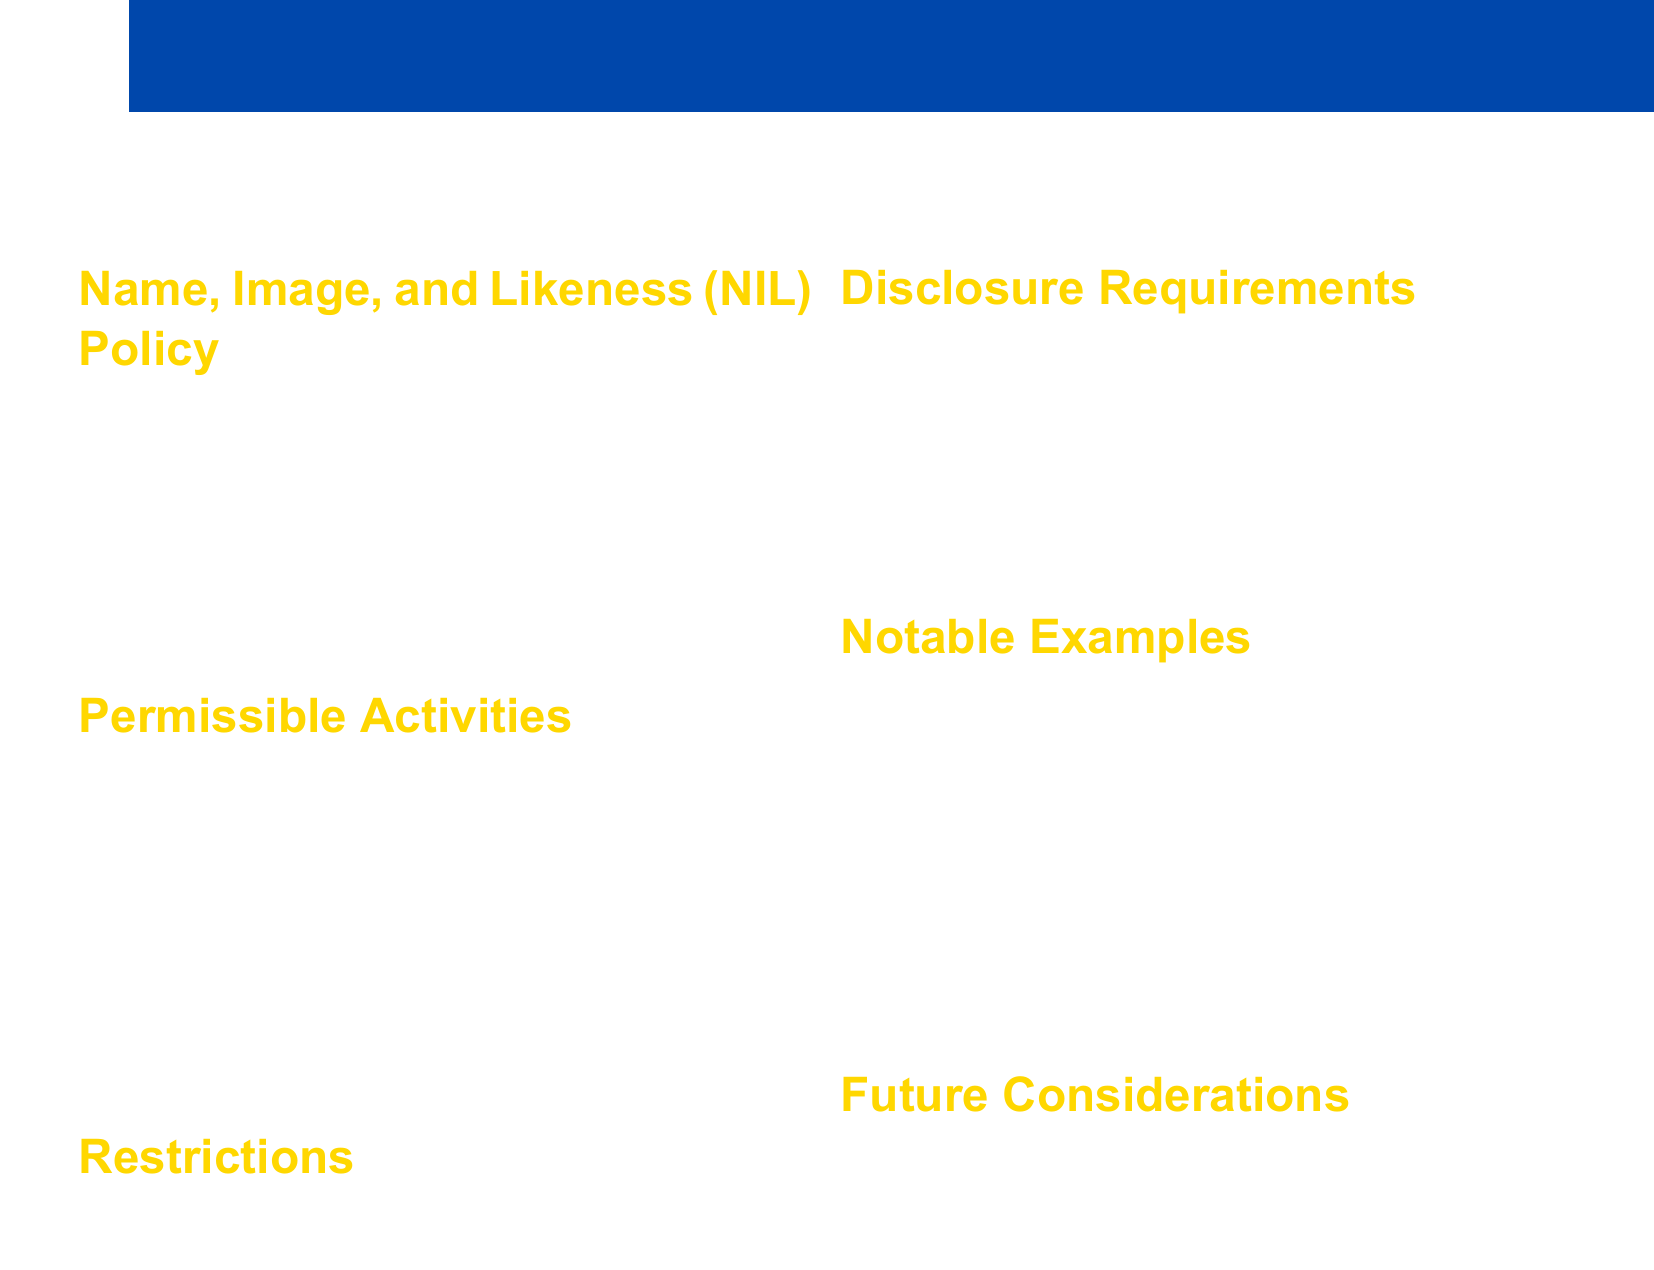What is the date the NIL policy was implemented? The document states that the NIL policy was implemented on July 1, 2021.
Answer: July 1, 2021 What activities are permissible for student-athletes? The document lists permissible activities, including autograph signings, social media endorsements, personal appearances, and promoting commercial products or services.
Answer: Autograph signings, social media endorsements, personal appearances, promoting commercial products or services What is one of the restrictions placed on student-athlete endorsements? The document mentions that there should be no pay-for-play arrangements as a restriction.
Answer: No pay-for-play arrangements Who is an example of a student-athlete mentioned in the document? The document provides examples, including Bryce Young, Paige Bueckers, and D'Eriq King as notable student-athletes.
Answer: Bryce Young What must student-athletes disclose about their NIL activities? The document requires student-athletes to report NIL activities to the school's compliance office and disclose terms of agreements and compensation received.
Answer: Report to compliance office, disclose terms and compensation What future consideration is mentioned regarding NIL rules? The document states that there may be potential federal legislation to standardize NIL rules as a future consideration.
Answer: Potential federal legislation What is a notable NIL deal amount mentioned in the document? The document states that Bryce Young is estimated to have $1 million in NIL deals.
Answer: $1 million 